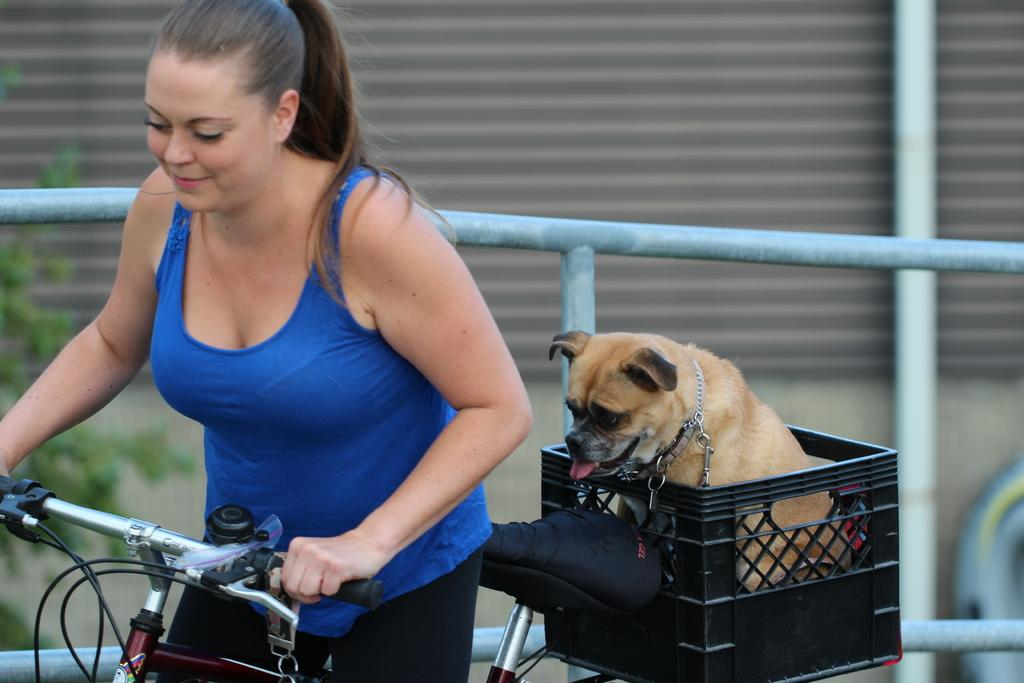Who is present in the image? There is a woman in the image. What is the woman doing in the image? The woman is smiling and holding a bicycle with her hand. What can be seen on the bicycle? There is a dog sitting on the basket of the bicycle. What is visible in the background of the image? There is a wall, a tree, and a rod in the background of the image. How much sugar is in the dog's food in the image? There is no information about the dog's food or sugar content in the image. 